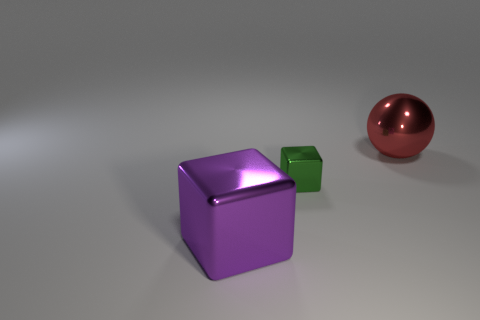Can you describe the mood or atmosphere of this image? The image conveys a minimalist and clean atmosphere, with a neutral background that emphasizes the simplicity and the intrinsic beauty of the shapes and colors of the objects. This combination can evoke a sense of calm and order. 